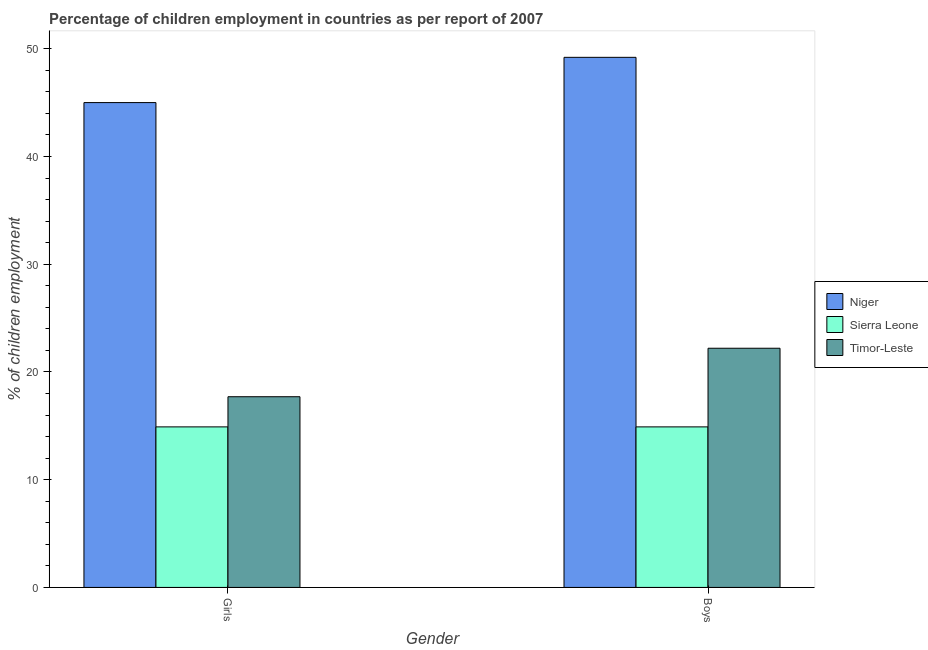How many different coloured bars are there?
Your response must be concise. 3. How many bars are there on the 1st tick from the left?
Offer a very short reply. 3. How many bars are there on the 1st tick from the right?
Offer a terse response. 3. What is the label of the 1st group of bars from the left?
Make the answer very short. Girls. Across all countries, what is the maximum percentage of employed girls?
Offer a very short reply. 45. In which country was the percentage of employed girls maximum?
Offer a terse response. Niger. In which country was the percentage of employed boys minimum?
Your response must be concise. Sierra Leone. What is the total percentage of employed girls in the graph?
Offer a very short reply. 77.6. What is the difference between the percentage of employed boys in Timor-Leste and that in Sierra Leone?
Provide a succinct answer. 7.3. What is the difference between the percentage of employed girls in Niger and the percentage of employed boys in Sierra Leone?
Make the answer very short. 30.1. What is the average percentage of employed girls per country?
Your answer should be very brief. 25.87. In how many countries, is the percentage of employed boys greater than 34 %?
Ensure brevity in your answer.  1. What is the ratio of the percentage of employed girls in Niger to that in Timor-Leste?
Your answer should be very brief. 2.54. What does the 3rd bar from the left in Boys represents?
Keep it short and to the point. Timor-Leste. What does the 1st bar from the right in Boys represents?
Provide a succinct answer. Timor-Leste. How many countries are there in the graph?
Ensure brevity in your answer.  3. What is the difference between two consecutive major ticks on the Y-axis?
Make the answer very short. 10. Does the graph contain any zero values?
Your answer should be compact. No. How many legend labels are there?
Ensure brevity in your answer.  3. What is the title of the graph?
Offer a very short reply. Percentage of children employment in countries as per report of 2007. What is the label or title of the Y-axis?
Your answer should be compact. % of children employment. What is the % of children employment in Niger in Girls?
Offer a very short reply. 45. What is the % of children employment in Niger in Boys?
Your response must be concise. 49.2. What is the % of children employment in Timor-Leste in Boys?
Offer a terse response. 22.2. Across all Gender, what is the maximum % of children employment in Niger?
Give a very brief answer. 49.2. Across all Gender, what is the maximum % of children employment in Sierra Leone?
Provide a succinct answer. 14.9. Across all Gender, what is the maximum % of children employment of Timor-Leste?
Your answer should be compact. 22.2. Across all Gender, what is the minimum % of children employment in Niger?
Provide a short and direct response. 45. Across all Gender, what is the minimum % of children employment in Timor-Leste?
Give a very brief answer. 17.7. What is the total % of children employment of Niger in the graph?
Ensure brevity in your answer.  94.2. What is the total % of children employment in Sierra Leone in the graph?
Offer a terse response. 29.8. What is the total % of children employment of Timor-Leste in the graph?
Your answer should be very brief. 39.9. What is the difference between the % of children employment in Sierra Leone in Girls and that in Boys?
Make the answer very short. 0. What is the difference between the % of children employment in Niger in Girls and the % of children employment in Sierra Leone in Boys?
Give a very brief answer. 30.1. What is the difference between the % of children employment in Niger in Girls and the % of children employment in Timor-Leste in Boys?
Provide a succinct answer. 22.8. What is the average % of children employment of Niger per Gender?
Ensure brevity in your answer.  47.1. What is the average % of children employment in Sierra Leone per Gender?
Ensure brevity in your answer.  14.9. What is the average % of children employment of Timor-Leste per Gender?
Offer a terse response. 19.95. What is the difference between the % of children employment in Niger and % of children employment in Sierra Leone in Girls?
Your response must be concise. 30.1. What is the difference between the % of children employment of Niger and % of children employment of Timor-Leste in Girls?
Provide a succinct answer. 27.3. What is the difference between the % of children employment of Sierra Leone and % of children employment of Timor-Leste in Girls?
Make the answer very short. -2.8. What is the difference between the % of children employment in Niger and % of children employment in Sierra Leone in Boys?
Ensure brevity in your answer.  34.3. What is the difference between the % of children employment of Niger and % of children employment of Timor-Leste in Boys?
Offer a very short reply. 27. What is the ratio of the % of children employment of Niger in Girls to that in Boys?
Your answer should be very brief. 0.91. What is the ratio of the % of children employment of Sierra Leone in Girls to that in Boys?
Keep it short and to the point. 1. What is the ratio of the % of children employment of Timor-Leste in Girls to that in Boys?
Ensure brevity in your answer.  0.8. What is the difference between the highest and the lowest % of children employment of Timor-Leste?
Your response must be concise. 4.5. 